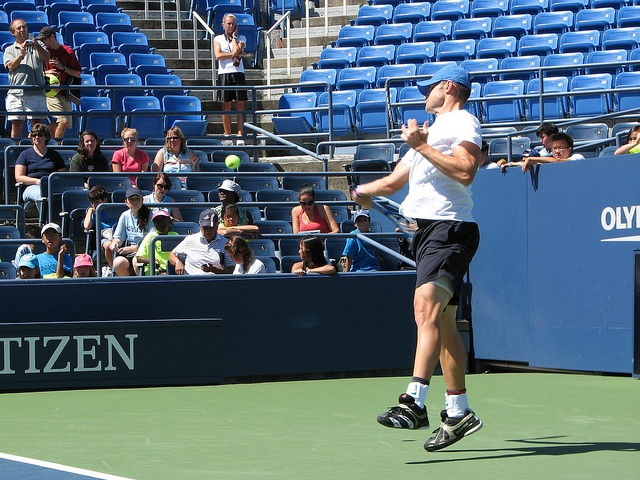Describe the objects in this image and their specific colors. I can see chair in gray, black, navy, lightblue, and blue tones, people in navy, black, gray, and white tones, people in navy, black, white, and gray tones, people in navy, black, white, maroon, and gray tones, and people in navy, white, black, darkgray, and gray tones in this image. 